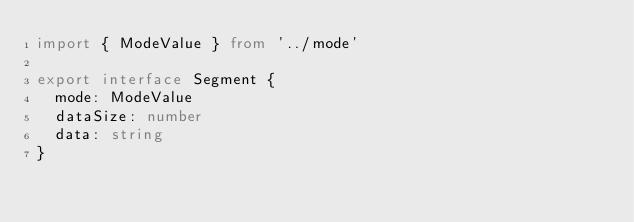Convert code to text. <code><loc_0><loc_0><loc_500><loc_500><_TypeScript_>import { ModeValue } from '../mode'

export interface Segment {
  mode: ModeValue
  dataSize: number
  data: string
}
</code> 